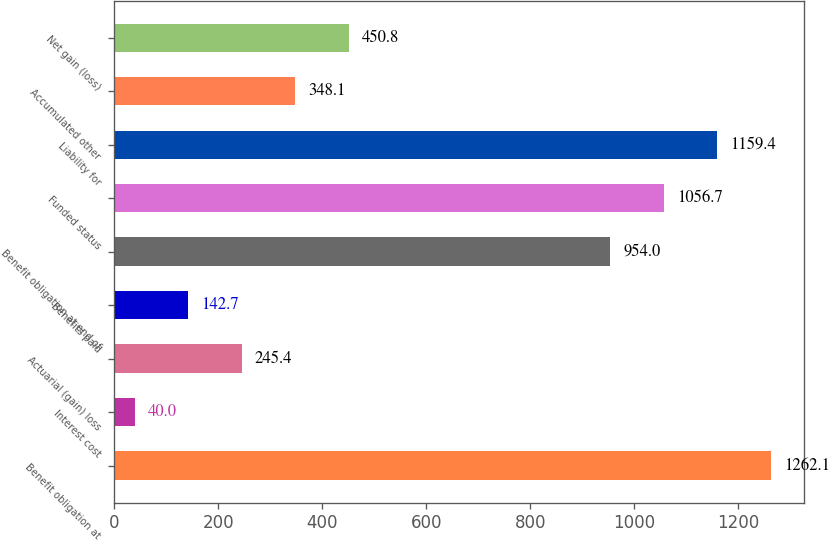Convert chart to OTSL. <chart><loc_0><loc_0><loc_500><loc_500><bar_chart><fcel>Benefit obligation at<fcel>Interest cost<fcel>Actuarial (gain) loss<fcel>Benefits paid<fcel>Benefit obligation at end of<fcel>Funded status<fcel>Liability for<fcel>Accumulated other<fcel>Net gain (loss)<nl><fcel>1262.1<fcel>40<fcel>245.4<fcel>142.7<fcel>954<fcel>1056.7<fcel>1159.4<fcel>348.1<fcel>450.8<nl></chart> 